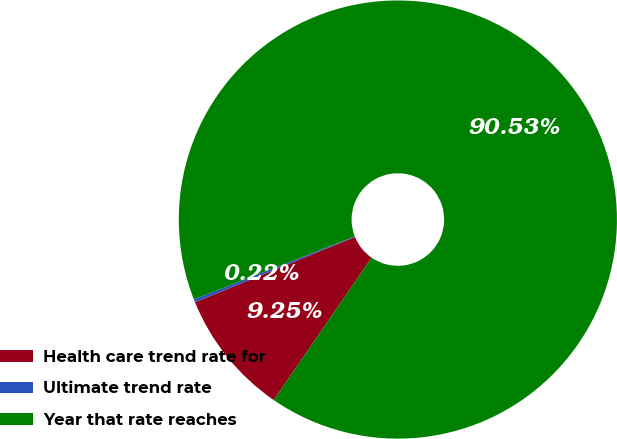Convert chart. <chart><loc_0><loc_0><loc_500><loc_500><pie_chart><fcel>Health care trend rate for<fcel>Ultimate trend rate<fcel>Year that rate reaches<nl><fcel>9.25%<fcel>0.22%<fcel>90.52%<nl></chart> 